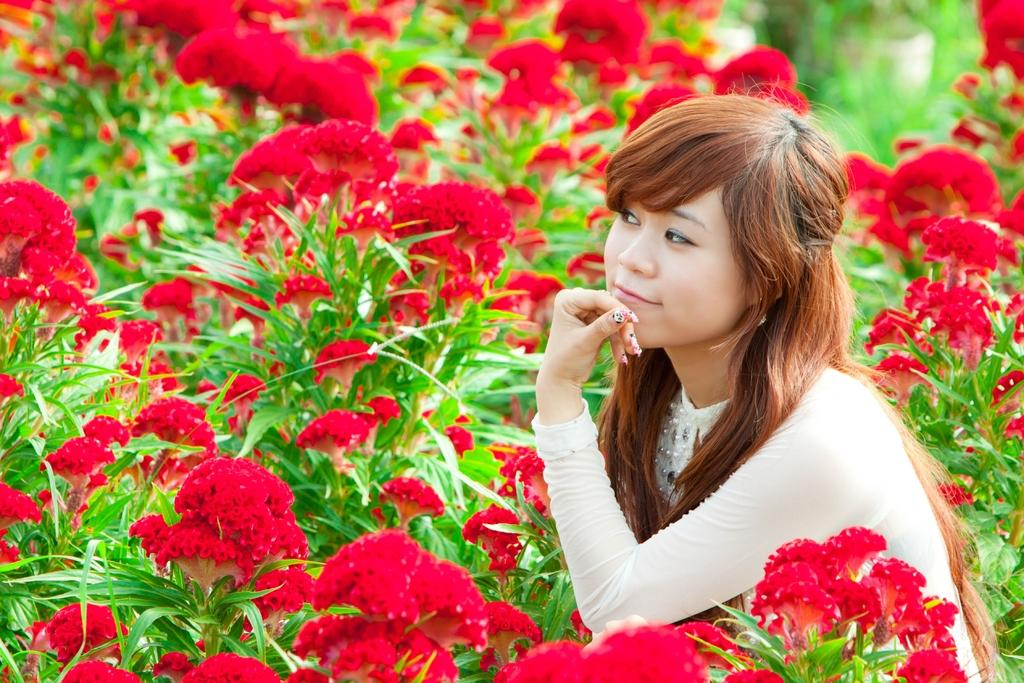Who is present in the image? There is a woman in the image. What expression does the woman have? The woman is smiling. What type of flora can be seen in the image? There are flowers and plants in the image. What type of drug can be seen in the woman's hand in the image? There is no drug present in the image; the woman is not holding anything in her hand. 